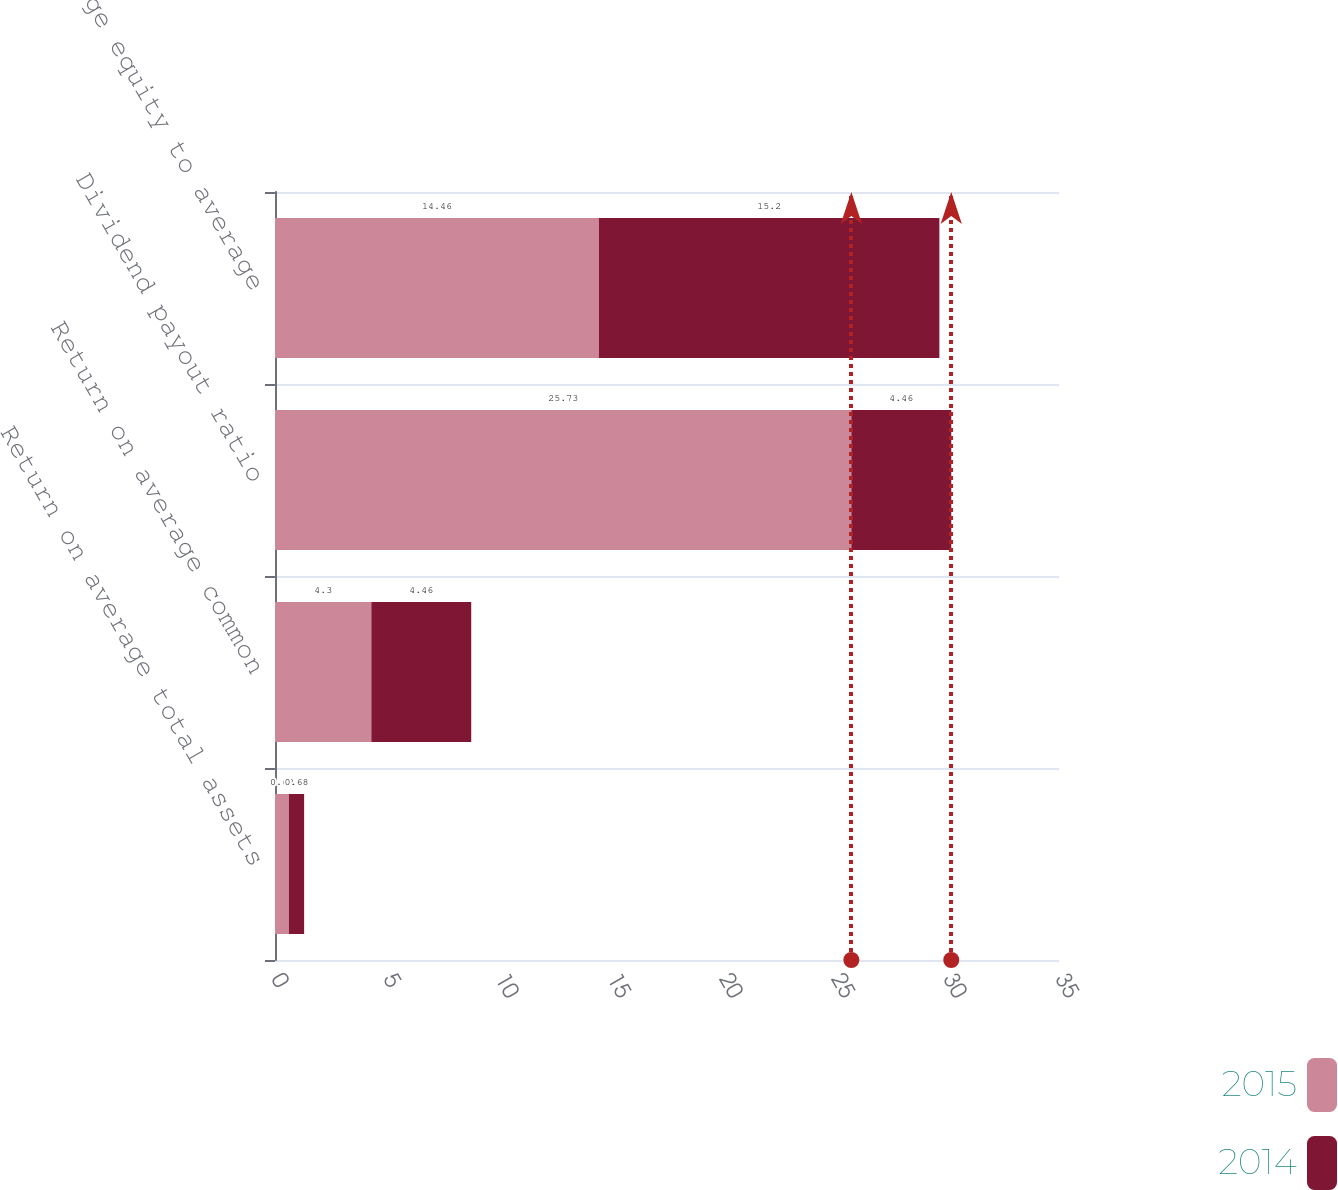Convert chart. <chart><loc_0><loc_0><loc_500><loc_500><stacked_bar_chart><ecel><fcel>Return on average total assets<fcel>Return on average common<fcel>Dividend payout ratio<fcel>Average equity to average<nl><fcel>2015<fcel>0.62<fcel>4.3<fcel>25.73<fcel>14.46<nl><fcel>2014<fcel>0.68<fcel>4.46<fcel>4.46<fcel>15.2<nl></chart> 